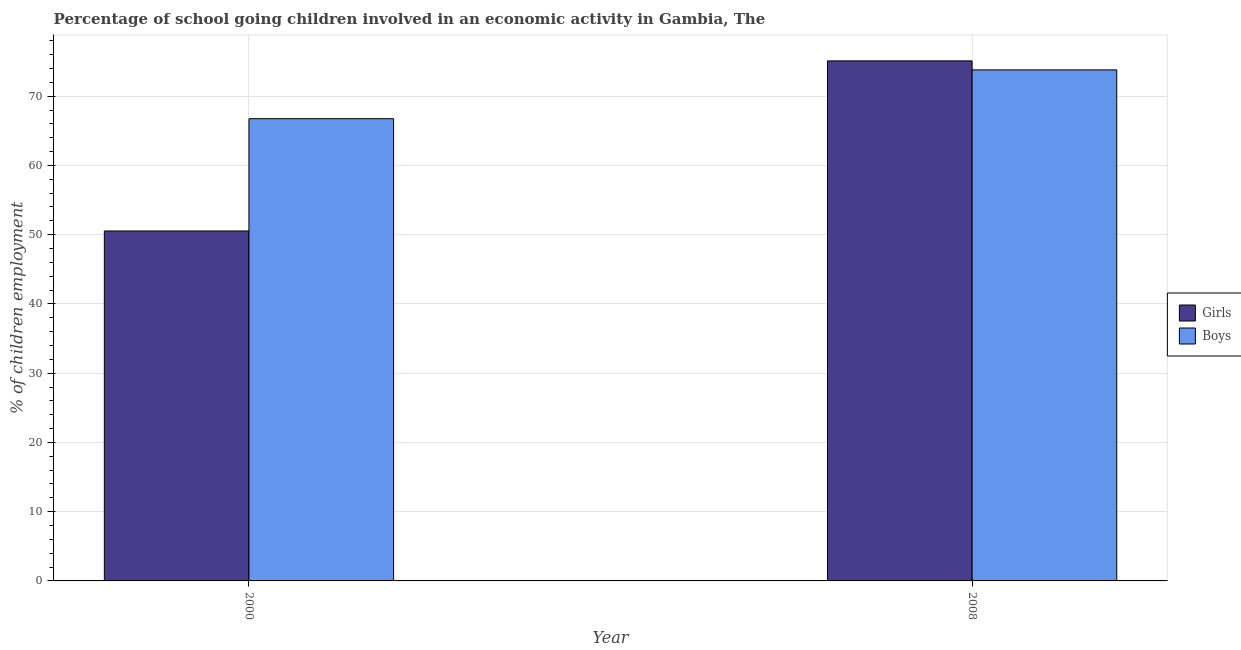How many different coloured bars are there?
Keep it short and to the point. 2. Are the number of bars per tick equal to the number of legend labels?
Offer a terse response. Yes. How many bars are there on the 2nd tick from the left?
Your answer should be very brief. 2. What is the label of the 1st group of bars from the left?
Your response must be concise. 2000. In how many cases, is the number of bars for a given year not equal to the number of legend labels?
Keep it short and to the point. 0. What is the percentage of school going boys in 2000?
Give a very brief answer. 66.75. Across all years, what is the maximum percentage of school going girls?
Your response must be concise. 75.1. Across all years, what is the minimum percentage of school going girls?
Make the answer very short. 50.54. What is the total percentage of school going boys in the graph?
Make the answer very short. 140.55. What is the difference between the percentage of school going boys in 2000 and that in 2008?
Offer a very short reply. -7.05. What is the difference between the percentage of school going girls in 2008 and the percentage of school going boys in 2000?
Your response must be concise. 24.56. What is the average percentage of school going boys per year?
Provide a succinct answer. 70.28. In the year 2008, what is the difference between the percentage of school going girls and percentage of school going boys?
Offer a terse response. 0. In how many years, is the percentage of school going girls greater than 54 %?
Ensure brevity in your answer.  1. What is the ratio of the percentage of school going girls in 2000 to that in 2008?
Offer a terse response. 0.67. Is the percentage of school going girls in 2000 less than that in 2008?
Provide a short and direct response. Yes. What does the 2nd bar from the left in 2008 represents?
Make the answer very short. Boys. What does the 2nd bar from the right in 2008 represents?
Ensure brevity in your answer.  Girls. How many bars are there?
Ensure brevity in your answer.  4. What is the difference between two consecutive major ticks on the Y-axis?
Provide a short and direct response. 10. Does the graph contain grids?
Provide a succinct answer. Yes. What is the title of the graph?
Your answer should be compact. Percentage of school going children involved in an economic activity in Gambia, The. Does "Technicians" appear as one of the legend labels in the graph?
Offer a terse response. No. What is the label or title of the X-axis?
Make the answer very short. Year. What is the label or title of the Y-axis?
Offer a very short reply. % of children employment. What is the % of children employment in Girls in 2000?
Your answer should be compact. 50.54. What is the % of children employment of Boys in 2000?
Provide a short and direct response. 66.75. What is the % of children employment in Girls in 2008?
Your answer should be compact. 75.1. What is the % of children employment of Boys in 2008?
Your answer should be very brief. 73.8. Across all years, what is the maximum % of children employment in Girls?
Offer a very short reply. 75.1. Across all years, what is the maximum % of children employment of Boys?
Your answer should be compact. 73.8. Across all years, what is the minimum % of children employment of Girls?
Your answer should be compact. 50.54. Across all years, what is the minimum % of children employment in Boys?
Your answer should be compact. 66.75. What is the total % of children employment of Girls in the graph?
Provide a succinct answer. 125.64. What is the total % of children employment of Boys in the graph?
Provide a short and direct response. 140.55. What is the difference between the % of children employment of Girls in 2000 and that in 2008?
Your response must be concise. -24.56. What is the difference between the % of children employment of Boys in 2000 and that in 2008?
Offer a terse response. -7.05. What is the difference between the % of children employment of Girls in 2000 and the % of children employment of Boys in 2008?
Keep it short and to the point. -23.26. What is the average % of children employment of Girls per year?
Ensure brevity in your answer.  62.82. What is the average % of children employment in Boys per year?
Ensure brevity in your answer.  70.28. In the year 2000, what is the difference between the % of children employment of Girls and % of children employment of Boys?
Keep it short and to the point. -16.21. What is the ratio of the % of children employment of Girls in 2000 to that in 2008?
Make the answer very short. 0.67. What is the ratio of the % of children employment of Boys in 2000 to that in 2008?
Make the answer very short. 0.9. What is the difference between the highest and the second highest % of children employment of Girls?
Give a very brief answer. 24.56. What is the difference between the highest and the second highest % of children employment in Boys?
Ensure brevity in your answer.  7.05. What is the difference between the highest and the lowest % of children employment of Girls?
Provide a short and direct response. 24.56. What is the difference between the highest and the lowest % of children employment in Boys?
Your answer should be very brief. 7.05. 